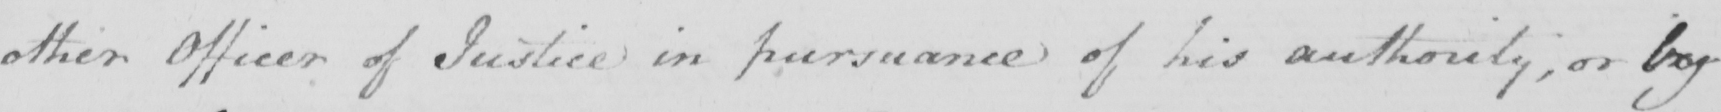Can you tell me what this handwritten text says? other Officer of Justice in pursuance of his authority , or by 